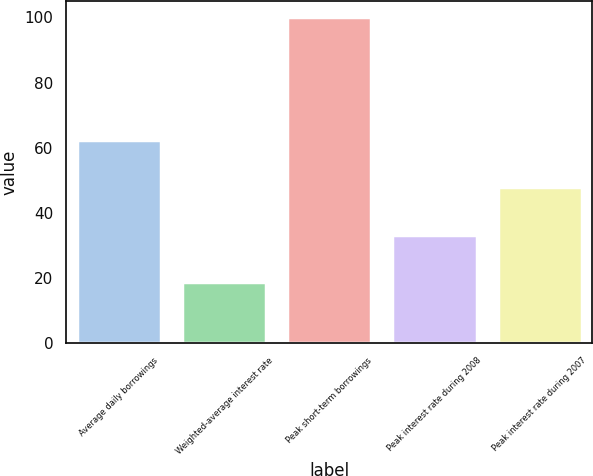Convert chart. <chart><loc_0><loc_0><loc_500><loc_500><bar_chart><fcel>Average daily borrowings<fcel>Weighted-average interest rate<fcel>Peak short-term borrowings<fcel>Peak interest rate during 2008<fcel>Peak interest rate during 2007<nl><fcel>62.37<fcel>18.57<fcel>100<fcel>33.17<fcel>47.77<nl></chart> 